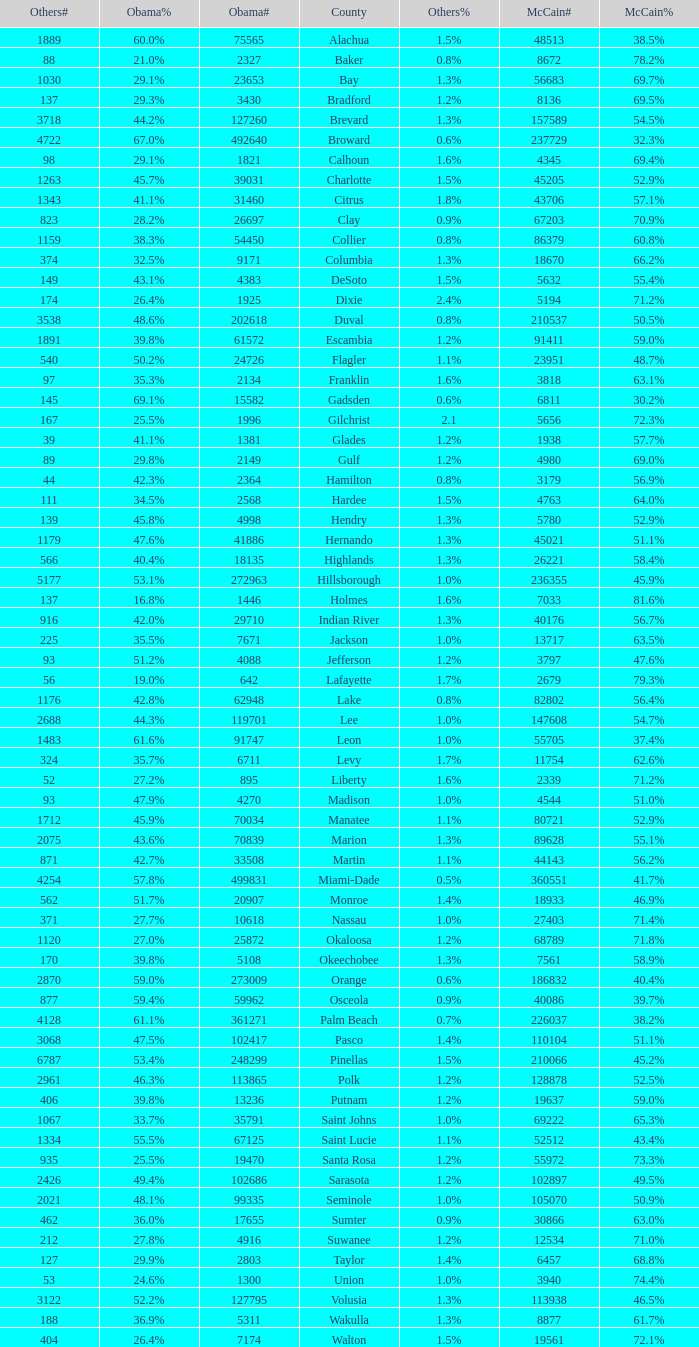How many numbers were recorded under McCain when Obama had 27.2% voters? 1.0. 